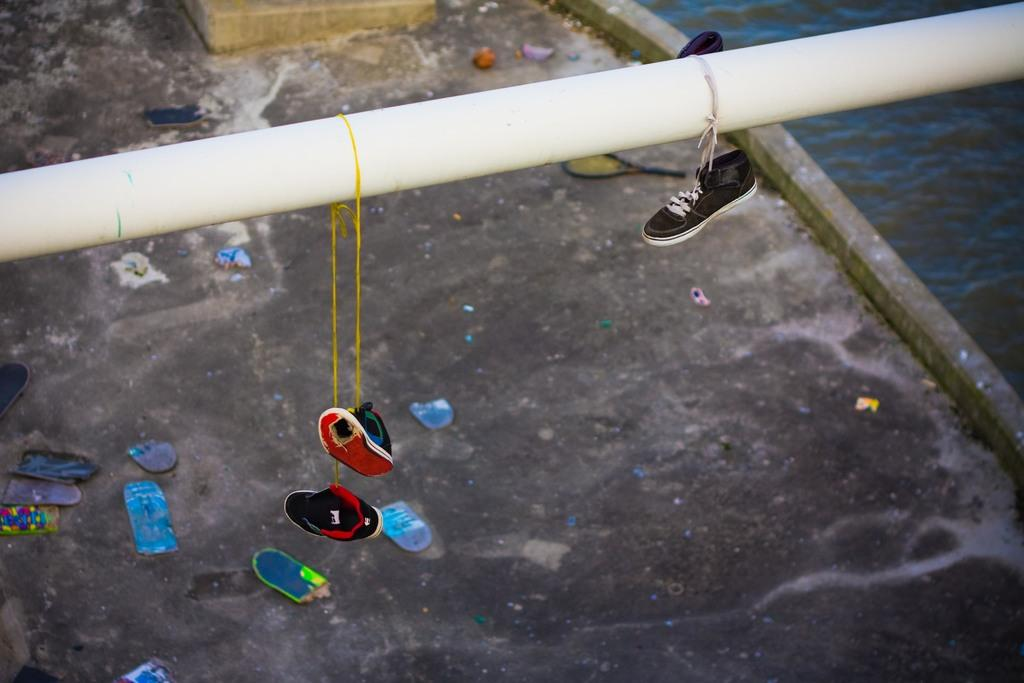What is hanging on the pipe in the image? There are shoes hanging on a pipe in the image. What can be seen on the ground in the image? There are objects on the ground in the image. Where is the water visible in the image? The water is visible in the right side corner of the image. What type of book is the person reading in the image? There is no person reading a book in the image; it only shows shoes hanging on a pipe, objects on the ground, and water in the corner. How many socks are visible in the image? There are no socks visible in the image; it only shows shoes hanging on a pipe, objects on the ground, and water in the corner. 